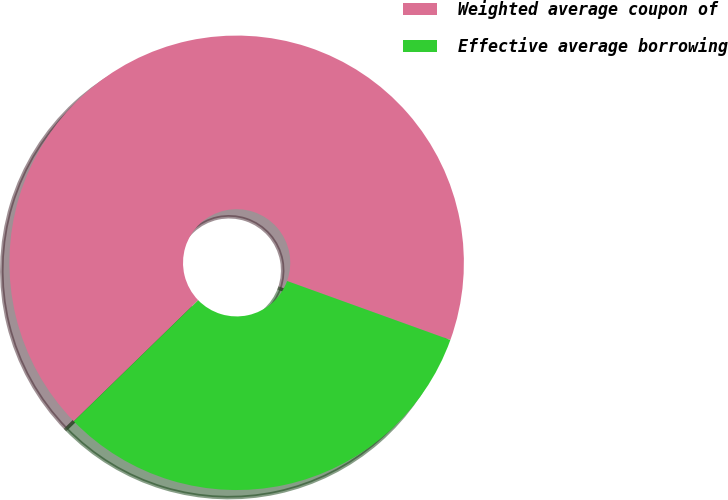Convert chart. <chart><loc_0><loc_0><loc_500><loc_500><pie_chart><fcel>Weighted average coupon of<fcel>Effective average borrowing<nl><fcel>67.8%<fcel>32.2%<nl></chart> 